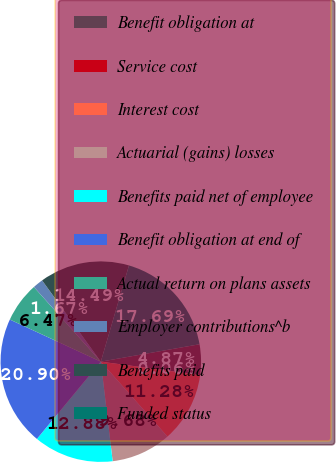<chart> <loc_0><loc_0><loc_500><loc_500><pie_chart><fcel>Benefit obligation at<fcel>Service cost<fcel>Interest cost<fcel>Actuarial (gains) losses<fcel>Benefits paid net of employee<fcel>Benefit obligation at end of<fcel>Actual return on plans assets<fcel>Employer contributions^b<fcel>Benefits paid<fcel>Funded status<nl><fcel>4.87%<fcel>0.06%<fcel>11.28%<fcel>9.68%<fcel>12.88%<fcel>20.9%<fcel>6.47%<fcel>1.67%<fcel>14.49%<fcel>17.69%<nl></chart> 